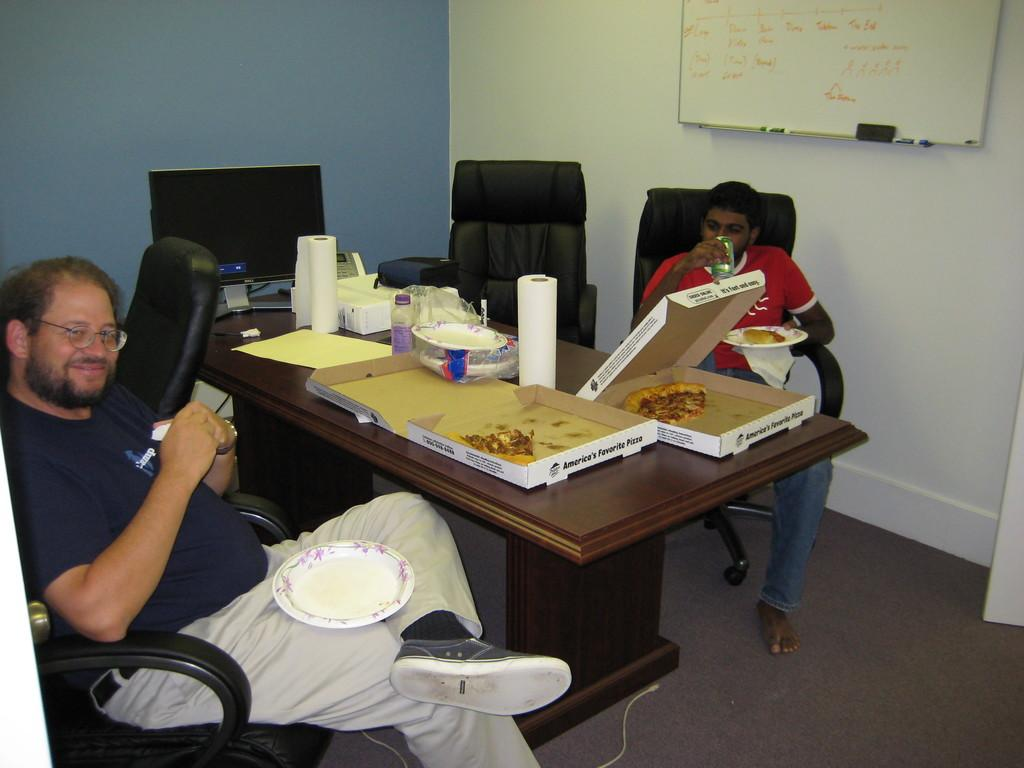How many people are in the image? There are two men in the image. What are the men doing in the image? The men are sitting on chairs. Where are the chairs located in relation to the table? The chairs are in front of a table. What can be found on the table? There are food items and a laptop on the table. What is on the wall in the image? There is a board on the wall. What type of grass is growing on the bed in the image? There is no bed or grass present in the image. How many stockings are hanging from the board on the wall? There are no stockings visible in the image; only a board is present on the wall. 